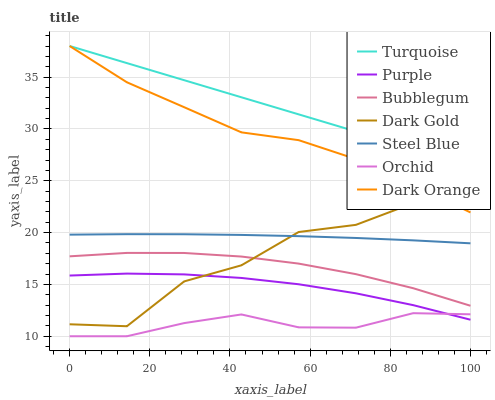Does Orchid have the minimum area under the curve?
Answer yes or no. Yes. Does Turquoise have the maximum area under the curve?
Answer yes or no. Yes. Does Dark Gold have the minimum area under the curve?
Answer yes or no. No. Does Dark Gold have the maximum area under the curve?
Answer yes or no. No. Is Turquoise the smoothest?
Answer yes or no. Yes. Is Dark Gold the roughest?
Answer yes or no. Yes. Is Dark Gold the smoothest?
Answer yes or no. No. Is Turquoise the roughest?
Answer yes or no. No. Does Dark Gold have the lowest value?
Answer yes or no. No. Does Dark Gold have the highest value?
Answer yes or no. No. Is Steel Blue less than Turquoise?
Answer yes or no. Yes. Is Dark Orange greater than Steel Blue?
Answer yes or no. Yes. Does Steel Blue intersect Turquoise?
Answer yes or no. No. 